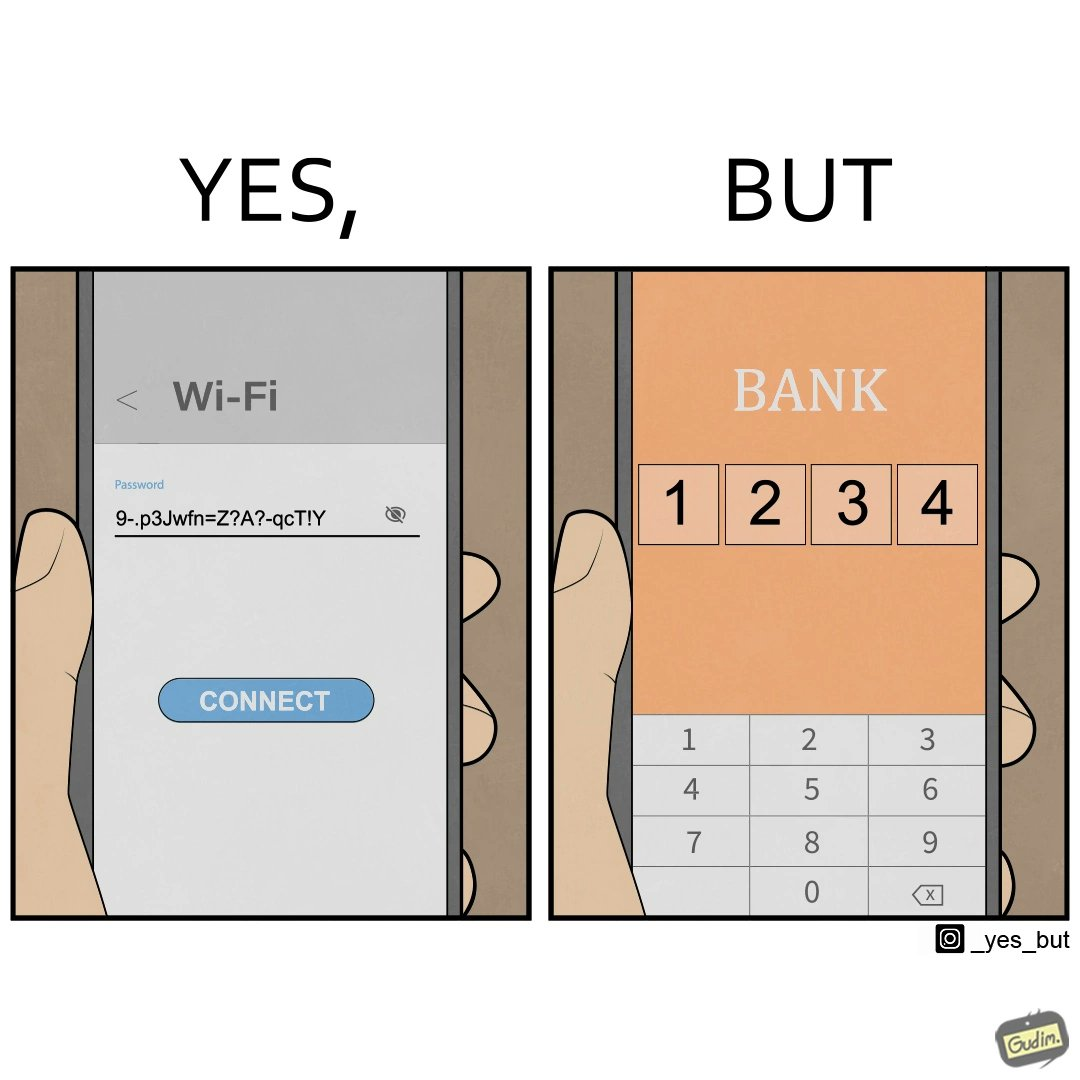What is shown in this image? The image is ironical, as a person sets a strong password for Wifi, while setting a very simple 4-digit PIN (1234 here) for online banking, where a much higher level of security would be required instead. 